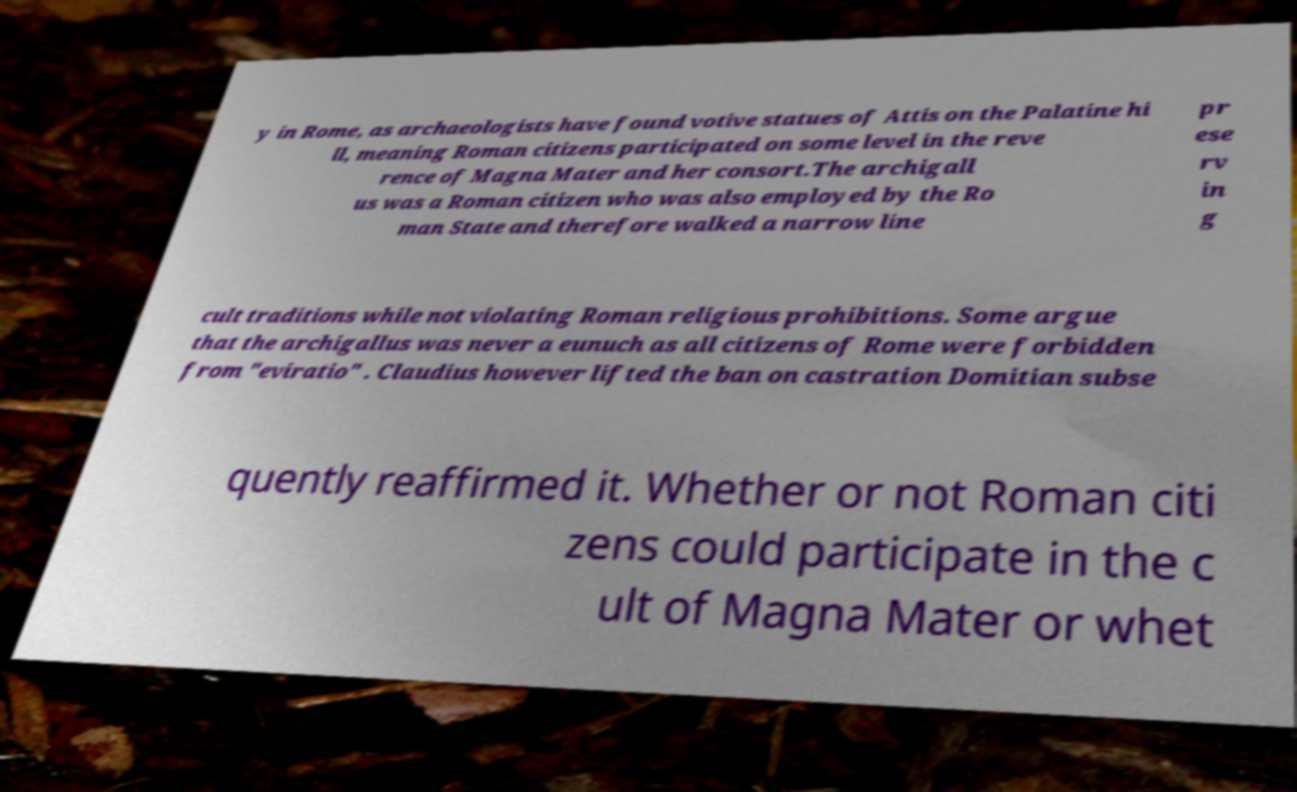Please read and relay the text visible in this image. What does it say? y in Rome, as archaeologists have found votive statues of Attis on the Palatine hi ll, meaning Roman citizens participated on some level in the reve rence of Magna Mater and her consort.The archigall us was a Roman citizen who was also employed by the Ro man State and therefore walked a narrow line pr ese rv in g cult traditions while not violating Roman religious prohibitions. Some argue that the archigallus was never a eunuch as all citizens of Rome were forbidden from "eviratio" . Claudius however lifted the ban on castration Domitian subse quently reaffirmed it. Whether or not Roman citi zens could participate in the c ult of Magna Mater or whet 